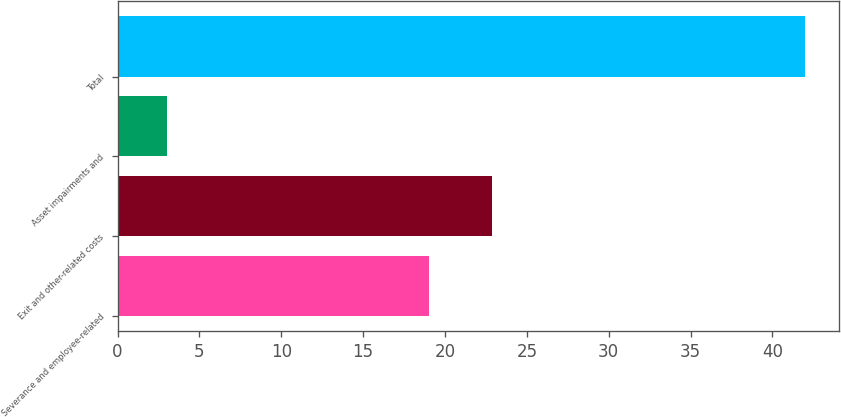Convert chart. <chart><loc_0><loc_0><loc_500><loc_500><bar_chart><fcel>Severance and employee-related<fcel>Exit and other-related costs<fcel>Asset impairments and<fcel>Total<nl><fcel>19<fcel>22.9<fcel>3<fcel>42<nl></chart> 